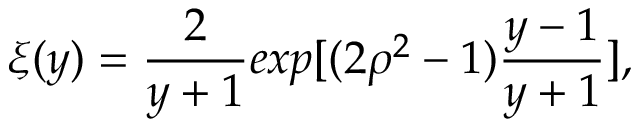<formula> <loc_0><loc_0><loc_500><loc_500>\xi ( y ) = \frac { 2 } y + 1 } e x p [ ( 2 \rho ^ { 2 } - 1 ) \frac { y - 1 } { y + 1 } ] ,</formula> 